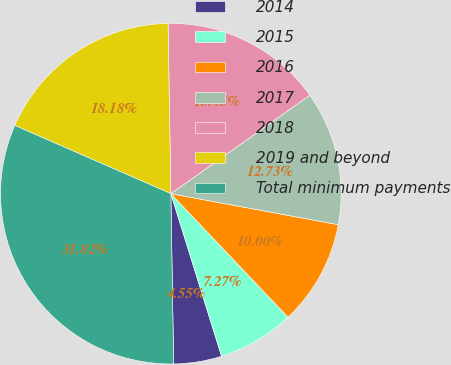Convert chart. <chart><loc_0><loc_0><loc_500><loc_500><pie_chart><fcel>2014<fcel>2015<fcel>2016<fcel>2017<fcel>2018<fcel>2019 and beyond<fcel>Total minimum payments<nl><fcel>4.55%<fcel>7.27%<fcel>10.0%<fcel>12.73%<fcel>15.45%<fcel>18.18%<fcel>31.82%<nl></chart> 